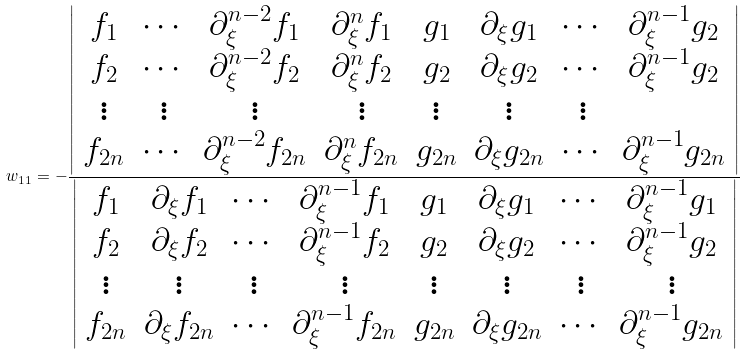<formula> <loc_0><loc_0><loc_500><loc_500>w _ { 1 1 } = - \frac { \left | \begin{array} { c c c c c c c c } f _ { 1 } & \cdots & \partial _ { \xi } ^ { n - 2 } f _ { 1 } & \partial _ { \xi } ^ { n } f _ { 1 } & g _ { 1 } & \partial _ { \xi } g _ { 1 } & \cdots & \partial _ { \xi } ^ { n - 1 } g _ { 2 } \\ f _ { 2 } & \cdots & \partial _ { \xi } ^ { n - 2 } f _ { 2 } & \partial _ { \xi } ^ { n } f _ { 2 } & g _ { 2 } & \partial _ { \xi } g _ { 2 } & \cdots & \partial _ { \xi } ^ { n - 1 } g _ { 2 } \\ \vdots & \vdots & \vdots & \vdots & \vdots & \vdots & \vdots \\ f _ { 2 n } & \cdots & \partial _ { \xi } ^ { n - 2 } f _ { 2 n } & \partial _ { \xi } ^ { n } f _ { 2 n } & g _ { 2 n } & \partial _ { \xi } g _ { 2 n } & \cdots & \partial _ { \xi } ^ { n - 1 } g _ { 2 n } \end{array} \right | } { \left | \begin{array} { c c c c c c c c } f _ { 1 } & \partial _ { \xi } f _ { 1 } & \cdots & \partial _ { \xi } ^ { n - 1 } f _ { 1 } & g _ { 1 } & \partial _ { \xi } g _ { 1 } & \cdots & \partial _ { \xi } ^ { n - 1 } g _ { 1 } \\ f _ { 2 } & \partial _ { \xi } f _ { 2 } & \cdots & \partial _ { \xi } ^ { n - 1 } f _ { 2 } & g _ { 2 } & \partial _ { \xi } g _ { 2 } & \cdots & \partial _ { \xi } ^ { n - 1 } g _ { 2 } \\ \vdots & \vdots & \vdots & \vdots & \vdots & \vdots & \vdots & \vdots \\ f _ { 2 n } & \partial _ { \xi } f _ { 2 n } & \cdots & \partial _ { \xi } ^ { n - 1 } f _ { 2 n } & g _ { 2 n } & \partial _ { \xi } g _ { 2 n } & \cdots & \partial _ { \xi } ^ { n - 1 } g _ { 2 n } \end{array} \right | }</formula> 